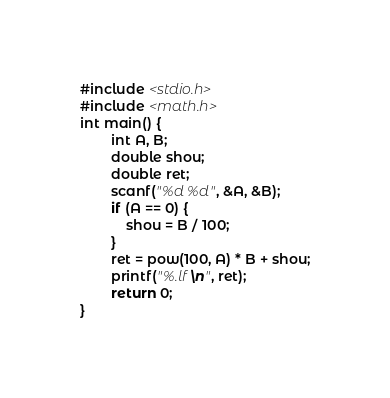<code> <loc_0><loc_0><loc_500><loc_500><_C_>#include <stdio.h>
#include <math.h>
int main() {
		int A, B;
		double shou;
		double ret;
		scanf("%d %d", &A, &B);
		if (A == 0) {
			shou = B / 100;
		}
		ret = pow(100, A) * B + shou;
		printf("%.lf\n", ret);
		return 0;
}
</code> 